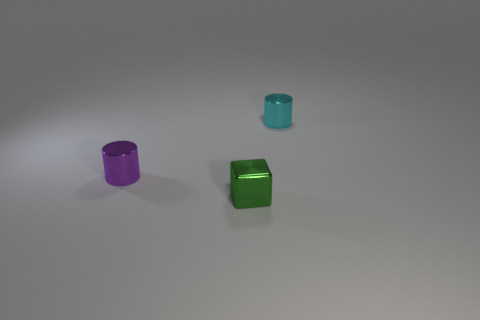Add 3 green cubes. How many objects exist? 6 Subtract all cubes. How many objects are left? 2 Add 1 small purple shiny cylinders. How many small purple shiny cylinders are left? 2 Add 3 small cyan shiny cylinders. How many small cyan shiny cylinders exist? 4 Subtract 0 cyan spheres. How many objects are left? 3 Subtract all metallic things. Subtract all yellow metallic cylinders. How many objects are left? 0 